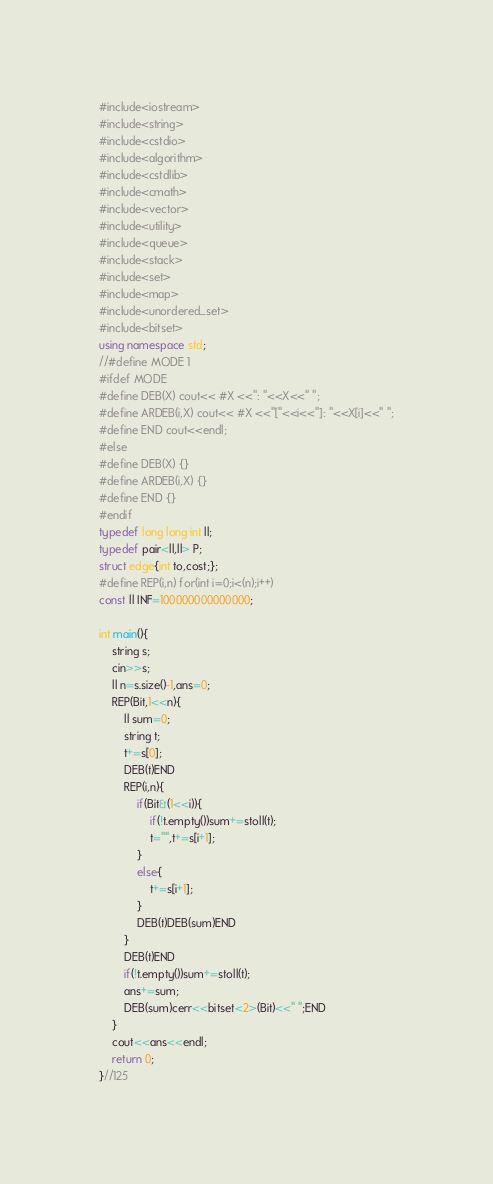Convert code to text. <code><loc_0><loc_0><loc_500><loc_500><_C++_>#include<iostream>
#include<string>
#include<cstdio>
#include<algorithm>
#include<cstdlib>
#include<cmath>
#include<vector>
#include<utility>
#include<queue>
#include<stack>
#include<set>
#include<map>
#include<unordered_set>
#include<bitset>
using namespace std;
//#define MODE 1
#ifdef MODE
#define DEB(X) cout<< #X <<": "<<X<<" ";
#define ARDEB(i,X) cout<< #X <<"["<<i<<"]: "<<X[i]<<" ";
#define END cout<<endl;
#else
#define DEB(X) {}
#define ARDEB(i,X) {}
#define END {}
#endif
typedef long long int ll;
typedef pair<ll,ll> P;
struct edge{int to,cost;};
#define REP(i,n) for(int i=0;i<(n);i++)
const ll INF=100000000000000;

int main(){
	string s;
	cin>>s;
	ll n=s.size()-1,ans=0;
	REP(Bit,1<<n){
		ll sum=0;
		string t;
		t+=s[0];
		DEB(t)END
		REP(i,n){
			if(Bit&(1<<i)){
				if(!t.empty())sum+=stoll(t);
				t="",t+=s[i+1];
			}
			else{
				t+=s[i+1];
			}
			DEB(t)DEB(sum)END
		}
		DEB(t)END
		if(!t.empty())sum+=stoll(t);
		ans+=sum;
		DEB(sum)cerr<<bitset<2>(Bit)<<" ";END
	}
	cout<<ans<<endl;
	return 0;
}//125</code> 